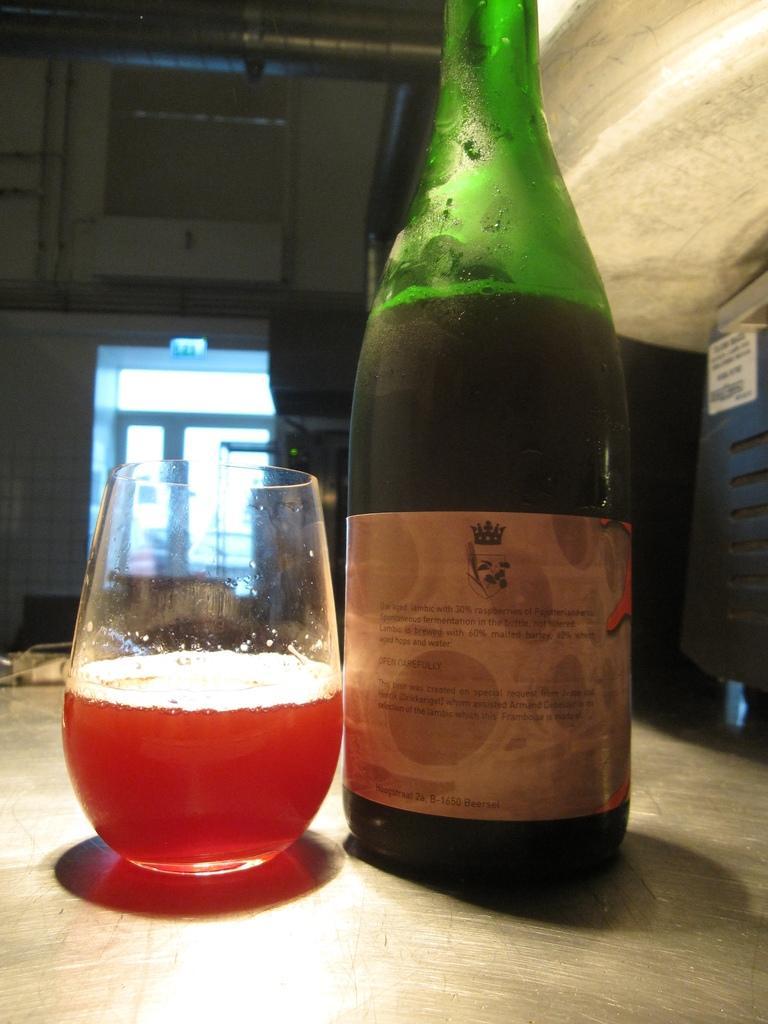How would you summarize this image in a sentence or two? In this image, There is a bottle which is in green color and there is a glass which contains red color liquid. 